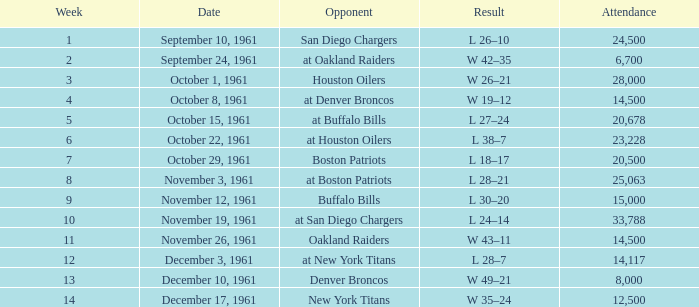What is the least week from october 15, 1961? 5.0. 